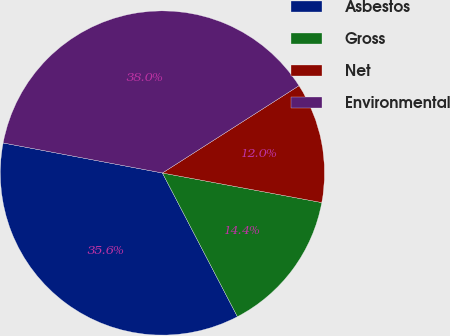Convert chart to OTSL. <chart><loc_0><loc_0><loc_500><loc_500><pie_chart><fcel>Asbestos<fcel>Gross<fcel>Net<fcel>Environmental<nl><fcel>35.62%<fcel>14.42%<fcel>11.97%<fcel>37.98%<nl></chart> 